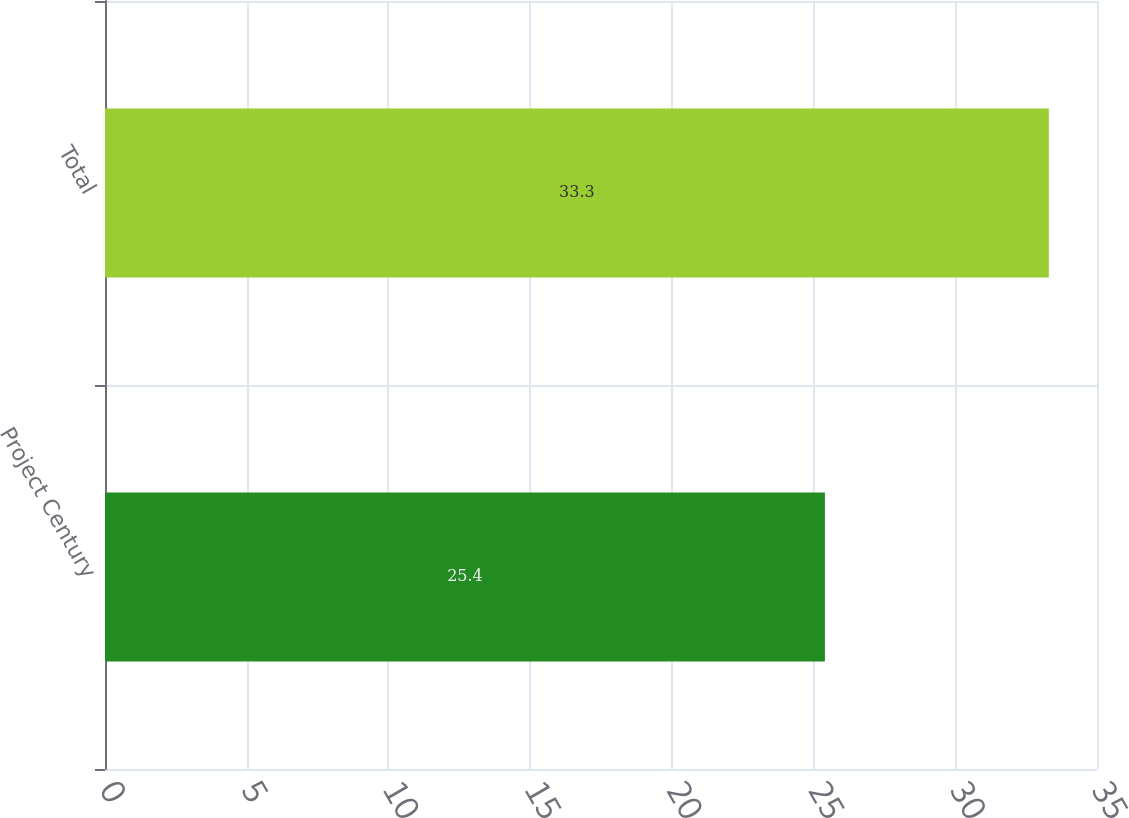Convert chart to OTSL. <chart><loc_0><loc_0><loc_500><loc_500><bar_chart><fcel>Project Century<fcel>Total<nl><fcel>25.4<fcel>33.3<nl></chart> 